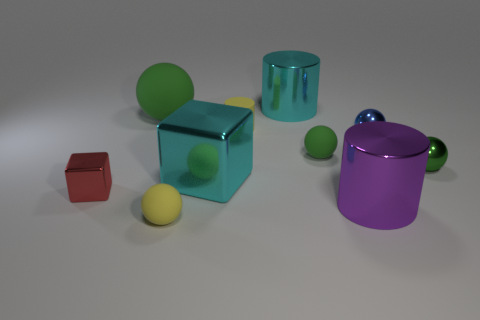Are there any big spheres that have the same material as the cyan cube?
Offer a very short reply. No. There is a green rubber object that is to the left of the large cyan object behind the blue sphere; are there any red shiny things that are behind it?
Provide a succinct answer. No. There is a green rubber thing that is the same size as the blue shiny thing; what shape is it?
Offer a very short reply. Sphere. There is a yellow rubber object that is behind the big cyan metallic block; does it have the same size as the cyan shiny thing that is in front of the blue ball?
Provide a succinct answer. No. What number of small red blocks are there?
Provide a short and direct response. 1. What is the size of the cyan metallic object that is behind the big thing that is left of the cyan thing in front of the tiny blue thing?
Give a very brief answer. Large. Is the rubber cylinder the same color as the small cube?
Keep it short and to the point. No. Is there any other thing that has the same size as the purple object?
Ensure brevity in your answer.  Yes. There is a blue ball; what number of things are in front of it?
Provide a short and direct response. 6. Are there an equal number of small red cubes behind the red metal object and green objects?
Offer a terse response. No. 